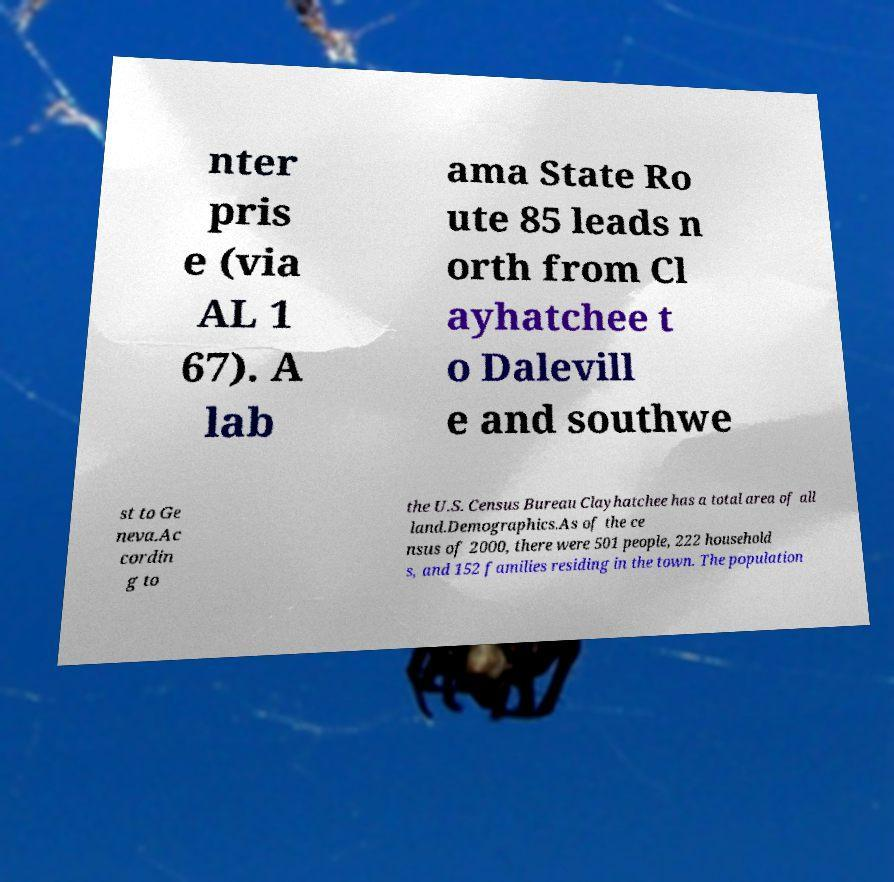Could you assist in decoding the text presented in this image and type it out clearly? nter pris e (via AL 1 67). A lab ama State Ro ute 85 leads n orth from Cl ayhatchee t o Dalevill e and southwe st to Ge neva.Ac cordin g to the U.S. Census Bureau Clayhatchee has a total area of all land.Demographics.As of the ce nsus of 2000, there were 501 people, 222 household s, and 152 families residing in the town. The population 